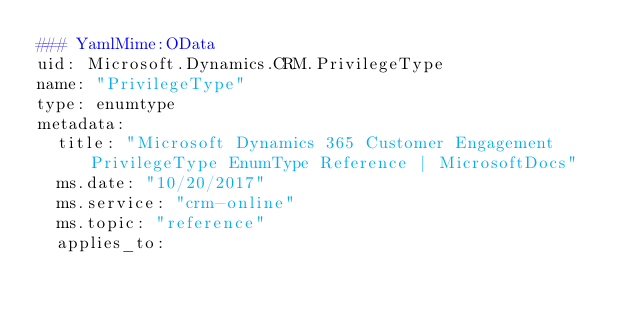<code> <loc_0><loc_0><loc_500><loc_500><_YAML_>### YamlMime:OData
uid: Microsoft.Dynamics.CRM.PrivilegeType
name: "PrivilegeType"
type: enumtype
metadata: 
  title: "Microsoft Dynamics 365 Customer Engagement PrivilegeType EnumType Reference | MicrosoftDocs"
  ms.date: "10/20/2017"
  ms.service: "crm-online"
  ms.topic: "reference"
  applies_to: </code> 